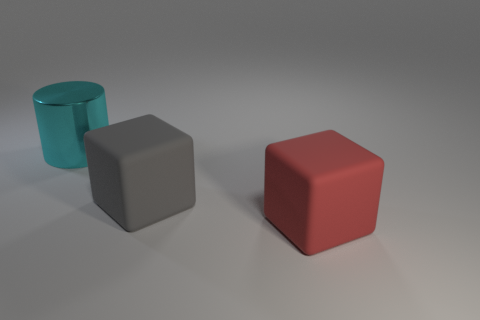How many other big matte objects are the same shape as the big gray rubber object?
Make the answer very short. 1. Are there any other things that have the same size as the cyan shiny thing?
Your response must be concise. Yes. What size is the matte thing to the left of the object that is in front of the large gray matte cube?
Ensure brevity in your answer.  Large. What is the material of the red cube that is the same size as the cyan cylinder?
Provide a short and direct response. Rubber. Is there a small green cube that has the same material as the gray object?
Your answer should be very brief. No. What color is the large object behind the big matte cube that is to the left of the large object that is in front of the large gray rubber object?
Offer a terse response. Cyan. There is a rubber block in front of the big gray matte cube; is it the same color as the object behind the large gray rubber block?
Offer a very short reply. No. Is there any other thing that is the same color as the cylinder?
Make the answer very short. No. Are there fewer big cubes that are to the left of the cyan metal thing than tiny red rubber things?
Your response must be concise. No. How many large blocks are there?
Make the answer very short. 2. 